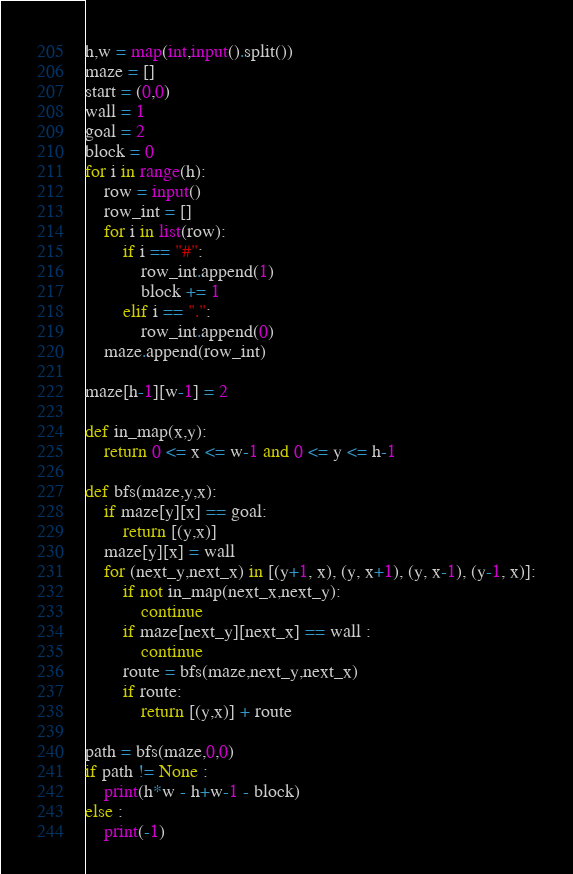Convert code to text. <code><loc_0><loc_0><loc_500><loc_500><_Python_>h,w = map(int,input().split())
maze = []
start = (0,0)
wall = 1
goal = 2
block = 0
for i in range(h):
	row = input()
	row_int = []
	for i in list(row):
		if i == "#":
			row_int.append(1)
			block += 1
		elif i == ".":
			row_int.append(0)
	maze.append(row_int)

maze[h-1][w-1] = 2

def in_map(x,y):
	return 0 <= x <= w-1 and 0 <= y <= h-1

def bfs(maze,y,x):
	if maze[y][x] == goal:
		return [(y,x)]
	maze[y][x] = wall
	for (next_y,next_x) in [(y+1, x), (y, x+1), (y, x-1), (y-1, x)]:
		if not in_map(next_x,next_y):
			continue
		if maze[next_y][next_x] == wall :
			continue
		route = bfs(maze,next_y,next_x)
		if route:
			return [(y,x)] + route

path = bfs(maze,0,0)
if path != None :
	print(h*w - h+w-1 - block)
else :
	print(-1)
</code> 